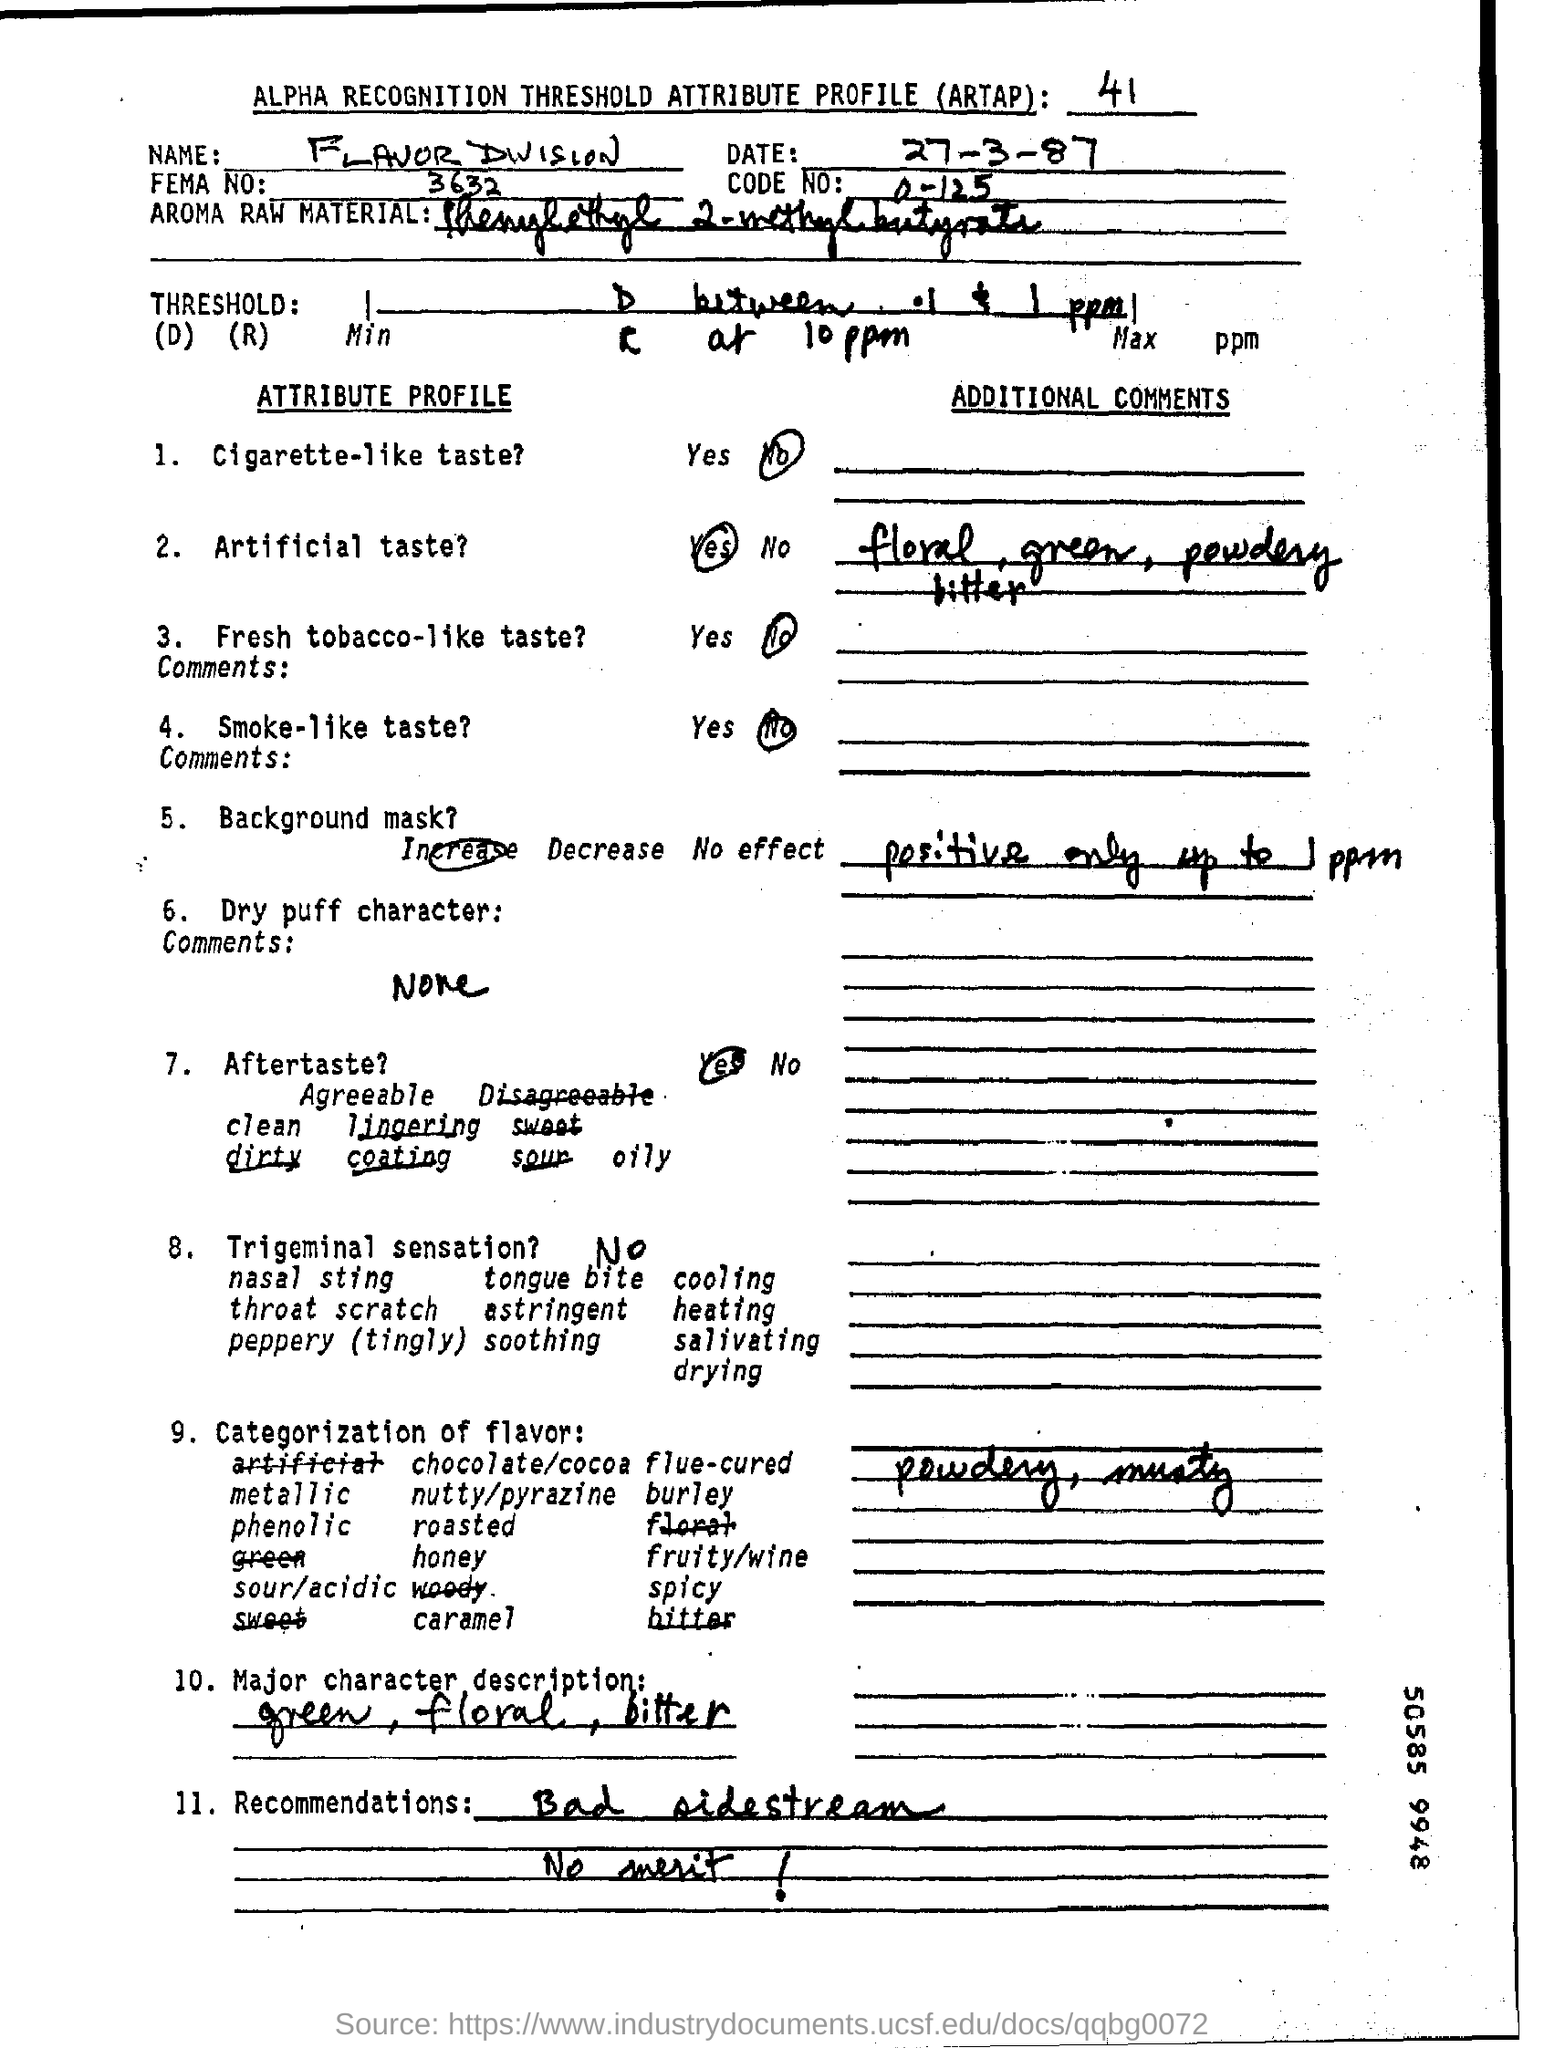Indicate a few pertinent items in this graphic. The code number is a range of 0 to 125, inclusive. FEMA number 3632..." refers to a specific identifier assigned by the Federal Emergency Management Agency. The date mentioned at the top of the document is 27th March 1987. 